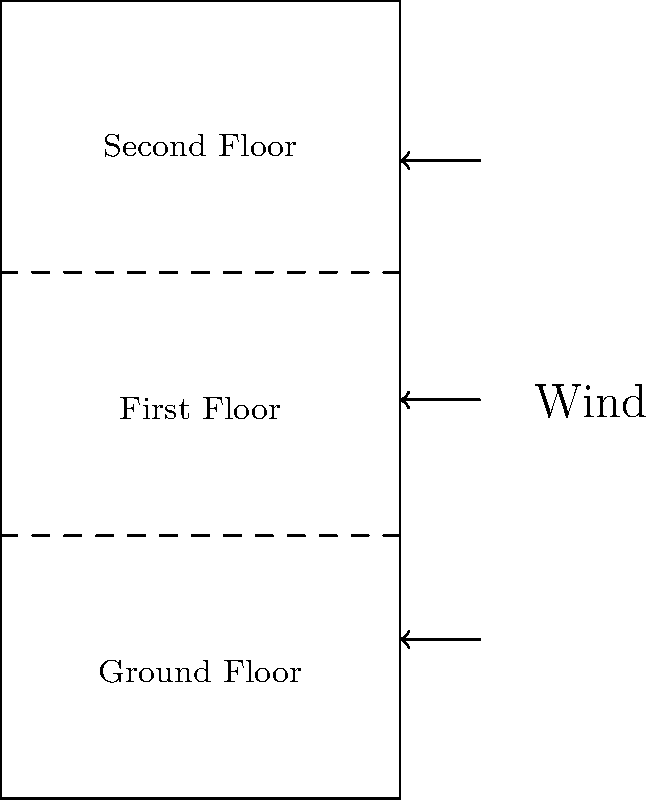In a three-story building subjected to high winds, as shown in the diagram, how does the distribution of lateral forces typically change from the ground floor to the top floor? To understand the distribution of lateral forces in a multi-story building during high winds, we need to consider the following steps:

1. Wind pressure distribution:
   - Wind pressure generally increases with height due to less ground interference.
   - This is described by the power law profile: $P(z) = P_0 (\frac{z}{z_0})^{\alpha}$, where $P(z)$ is pressure at height $z$, $P_0$ is reference pressure, $z_0$ is reference height, and $\alpha$ is terrain-dependent exponent.

2. Force calculation:
   - Lateral force on each floor is proportional to wind pressure and the floor's tributary area.
   - Force $F = P \times A$, where $P$ is wind pressure and $A$ is tributary area.

3. Tributary area consideration:
   - Top floor has half the tributary area of middle floors.
   - Middle floors have full tributary area.
   - Ground floor has half the tributary area of middle floors.

4. Resulting force distribution:
   - Despite smaller tributary area, top floor often experiences largest force due to highest wind pressure.
   - Middle floor typically has second-largest force.
   - Ground floor usually experiences smallest force due to lowest wind pressure and smaller tributary area.

5. Additional factors:
   - Building shape and surrounding structures can affect wind flow and pressure distribution.
   - Dynamic effects may cause force amplification, especially in tall, flexible structures.

Given the typical distribution pattern and the factors involved, the lateral forces generally increase from the ground floor to the top floor in a three-story building during high winds.
Answer: Forces typically increase from ground to top floor. 